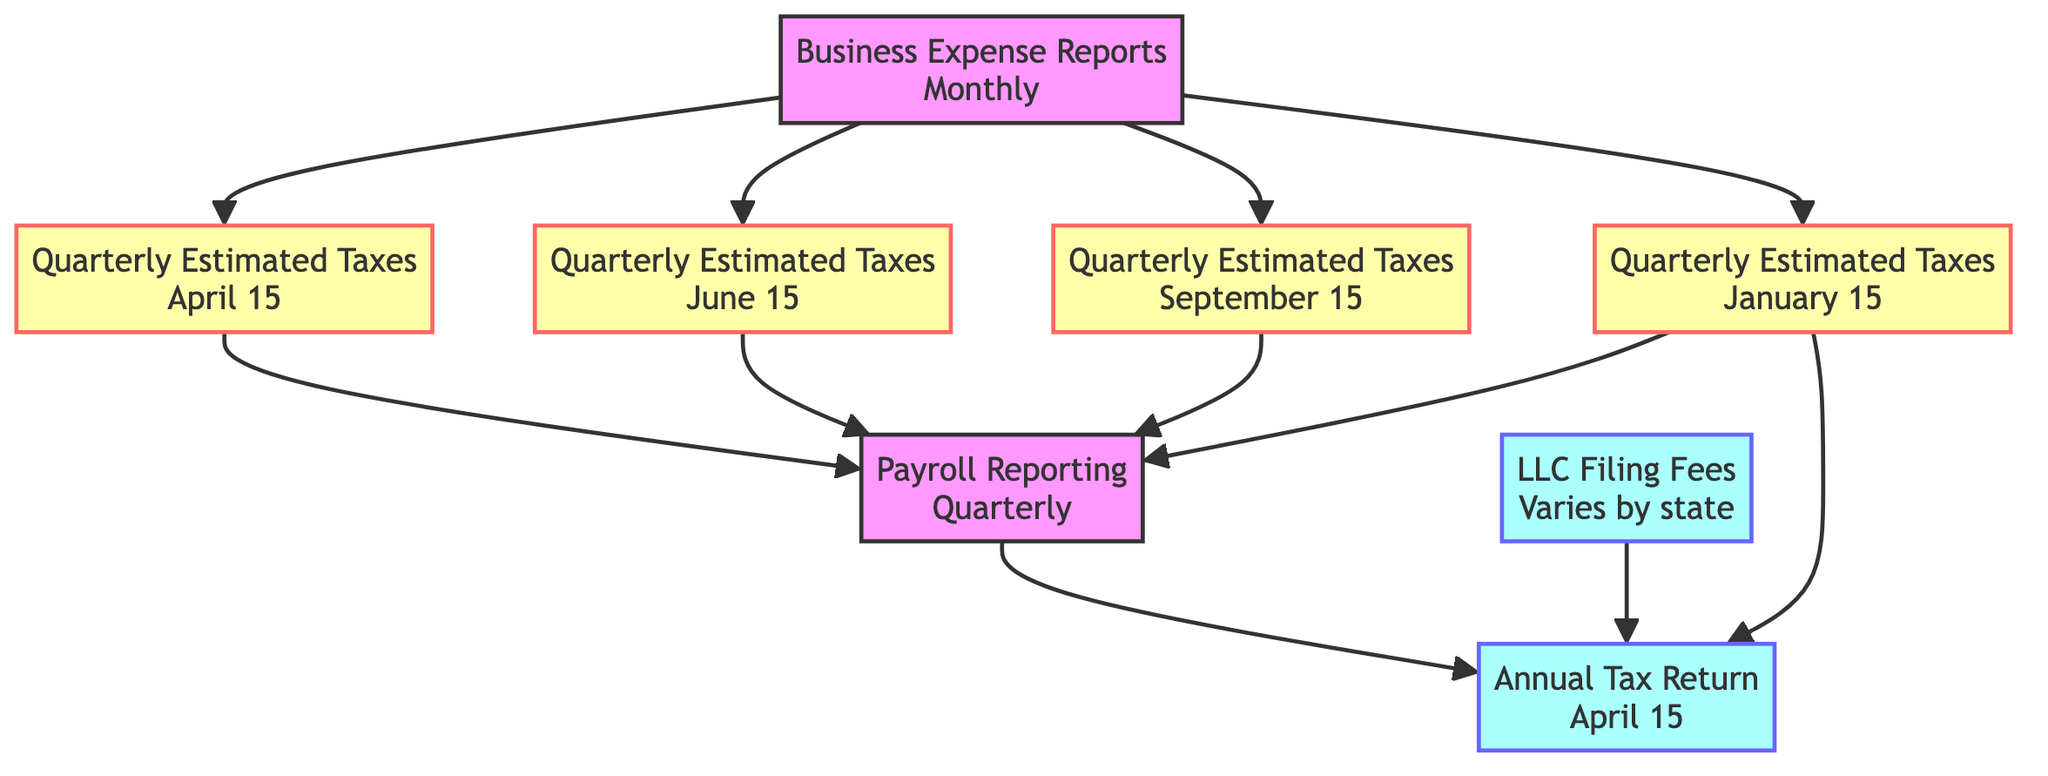What is the date for the Annual Tax Return? The diagram indicates that the Annual Tax Return is due on April 15, as labeled on the node connecting to it.
Answer: April 15 How many Quarterly Estimated Taxes deadlines are there? By counting the nodes labeled "Quarterly Estimated Taxes" in the diagram, we can see there are four distinct deadlines listed.
Answer: 4 Which filing affects the Quarterly Estimated Taxes? The diagram shows directed edges from the Business Expense Reports node to all four Quarterly Estimated Taxes deadlines, indicating that these reports are a prerequisite for the estimated tax payments.
Answer: Business Expense Reports What is the last due date for Quarterly Estimated Taxes? The last node labeled Quarter Estimated Taxes lists January 15 (of the following year) as the deadline, as it is the last entry in the sequential order.
Answer: January 15 (of the following year) Which two filings are required before submitting the Annual Tax Return? The diagram shows directed edges leading into the Annual Tax Return from Payroll Reporting and the last Quarterly Estimated Taxes (January 15), indicating both must be satisfied before the annual return can be filed.
Answer: Payroll Reporting, Quarterly Estimated Taxes What is the relationship between Payroll Reporting and Annual Tax Return? The directed edge connecting Payroll Reporting to the Annual Tax Return indicates that Payroll Reporting is a prerequisite task that must be completed before the Annual Tax Return is filed.
Answer: Prerequisite Which filing is dependent on the LLC Filing Fees? The directed edge from LLC Filing Fees to Annual Tax Return signifies that completion of the LLC Filing Fees is necessary before the Annual Tax Return can be submitted.
Answer: Annual Tax Return What is the common deadline for Business Expense Reports? The diagram consistently indicates that Business Expense Reports are due on the last day of each month, making it a recurring monthly obligation.
Answer: Last day of each month 